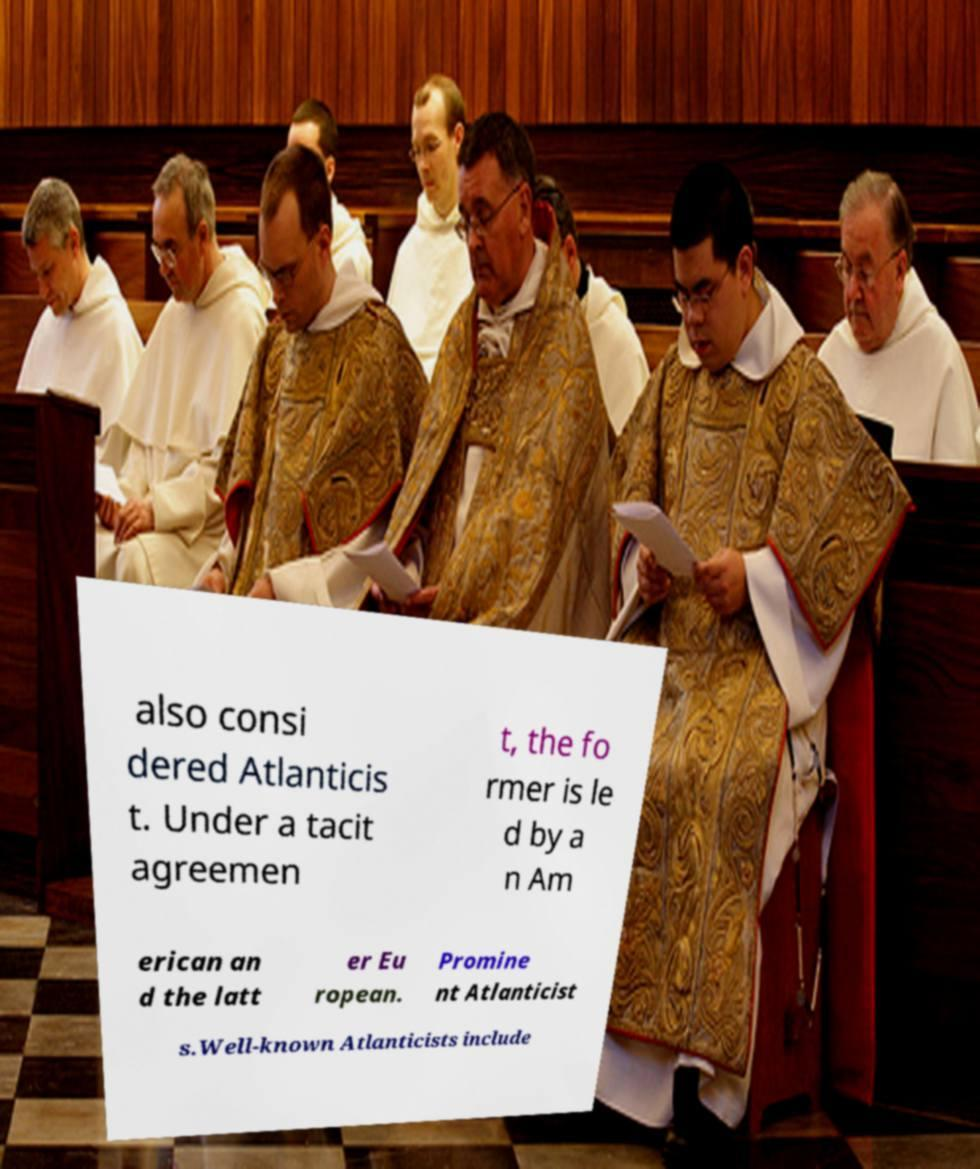Can you read and provide the text displayed in the image?This photo seems to have some interesting text. Can you extract and type it out for me? also consi dered Atlanticis t. Under a tacit agreemen t, the fo rmer is le d by a n Am erican an d the latt er Eu ropean. Promine nt Atlanticist s.Well-known Atlanticists include 